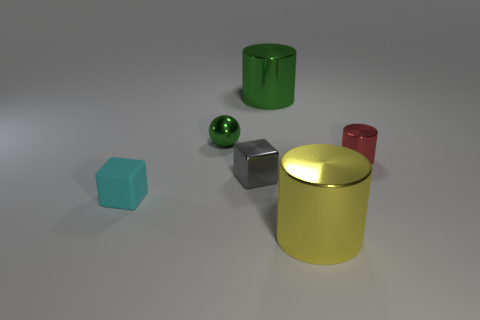Are there any other things that have the same material as the cyan cube?
Your response must be concise. No. Is there any other thing of the same color as the small ball?
Provide a succinct answer. Yes. Do the red metallic object and the big yellow thing have the same shape?
Offer a terse response. Yes. What size is the green object that is behind the small thing that is behind the metal thing right of the big yellow shiny cylinder?
Your answer should be very brief. Large. What number of other things are made of the same material as the big green cylinder?
Ensure brevity in your answer.  4. The big cylinder that is behind the small green thing is what color?
Make the answer very short. Green. What material is the large thing in front of the large object that is on the left side of the large yellow object that is in front of the shiny ball made of?
Your response must be concise. Metal. Is there another tiny gray metallic thing of the same shape as the gray shiny object?
Ensure brevity in your answer.  No. The cyan rubber object that is the same size as the metallic ball is what shape?
Your answer should be very brief. Cube. What number of metal objects are both behind the tiny cyan matte object and right of the tiny metal sphere?
Offer a terse response. 3. 